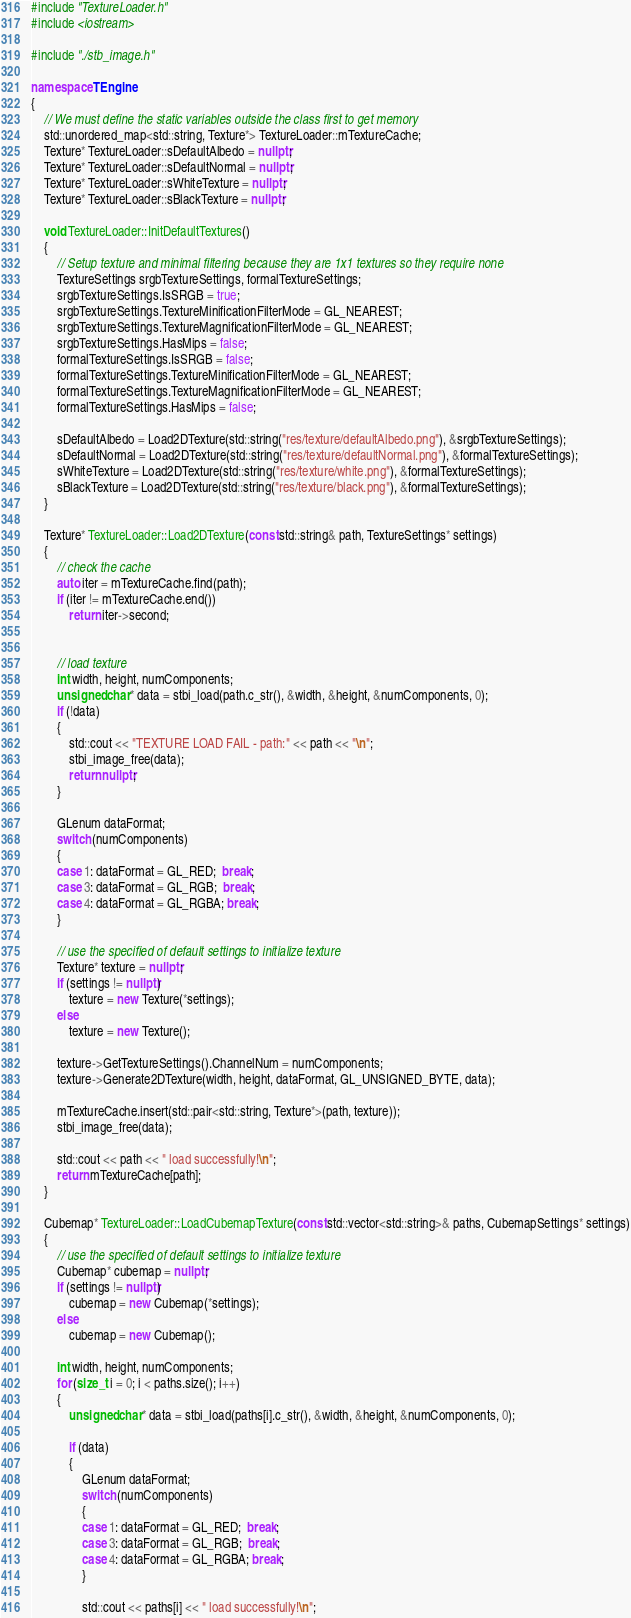<code> <loc_0><loc_0><loc_500><loc_500><_C++_>#include "TextureLoader.h"
#include <iostream>

#include "./stb_image.h"

namespace TEngine
{
	// We must define the static variables outside the class first to get memory
	std::unordered_map<std::string, Texture*> TextureLoader::mTextureCache;
	Texture* TextureLoader::sDefaultAlbedo = nullptr;
	Texture* TextureLoader::sDefaultNormal = nullptr;
	Texture* TextureLoader::sWhiteTexture = nullptr;
	Texture* TextureLoader::sBlackTexture = nullptr;

	void TextureLoader::InitDefaultTextures()
	{
		// Setup texture and minimal filtering because they are 1x1 textures so they require none
		TextureSettings srgbTextureSettings, formalTextureSettings;
		srgbTextureSettings.IsSRGB = true;
		srgbTextureSettings.TextureMinificationFilterMode = GL_NEAREST;
		srgbTextureSettings.TextureMagnificationFilterMode = GL_NEAREST;
		srgbTextureSettings.HasMips = false;
		formalTextureSettings.IsSRGB = false;
		formalTextureSettings.TextureMinificationFilterMode = GL_NEAREST;
		formalTextureSettings.TextureMagnificationFilterMode = GL_NEAREST;
		formalTextureSettings.HasMips = false;

		sDefaultAlbedo = Load2DTexture(std::string("res/texture/defaultAlbedo.png"), &srgbTextureSettings);
		sDefaultNormal = Load2DTexture(std::string("res/texture/defaultNormal.png"), &formalTextureSettings);
		sWhiteTexture = Load2DTexture(std::string("res/texture/white.png"), &formalTextureSettings);
		sBlackTexture = Load2DTexture(std::string("res/texture/black.png"), &formalTextureSettings);
	}

	Texture* TextureLoader::Load2DTexture(const std::string& path, TextureSettings* settings)
	{
		// check the cache
		auto iter = mTextureCache.find(path);
		if (iter != mTextureCache.end())
			return iter->second;


		// load texture
		int width, height, numComponents;
		unsigned char* data = stbi_load(path.c_str(), &width, &height, &numComponents, 0);
		if (!data)
		{
			std::cout << "TEXTURE LOAD FAIL - path:" << path << "\n";
			stbi_image_free(data);
			return nullptr;
		}

		GLenum dataFormat;
		switch (numComponents)
		{
		case 1: dataFormat = GL_RED;  break;
		case 3: dataFormat = GL_RGB;  break;
		case 4: dataFormat = GL_RGBA; break;
		}

		// use the specified of default settings to initialize texture
		Texture* texture = nullptr;
		if (settings != nullptr)
			texture = new Texture(*settings);
		else
			texture = new Texture();

		texture->GetTextureSettings().ChannelNum = numComponents;
		texture->Generate2DTexture(width, height, dataFormat, GL_UNSIGNED_BYTE, data);

		mTextureCache.insert(std::pair<std::string, Texture*>(path, texture));
		stbi_image_free(data);

		std::cout << path << " load successfully!\n";
		return mTextureCache[path];
	}

	Cubemap* TextureLoader::LoadCubemapTexture(const std::vector<std::string>& paths, CubemapSettings* settings)
	{
		// use the specified of default settings to initialize texture
		Cubemap* cubemap = nullptr;
		if (settings != nullptr)
			cubemap = new Cubemap(*settings);
		else
			cubemap = new Cubemap();

		int width, height, numComponents;
		for (size_t i = 0; i < paths.size(); i++)
		{
			unsigned char* data = stbi_load(paths[i].c_str(), &width, &height, &numComponents, 0);

			if (data)
			{
				GLenum dataFormat;
				switch (numComponents)
				{
				case 1: dataFormat = GL_RED;  break;
				case 3: dataFormat = GL_RGB;  break;
				case 4: dataFormat = GL_RGBA; break;
				}

				std::cout << paths[i] << " load successfully!\n";</code> 